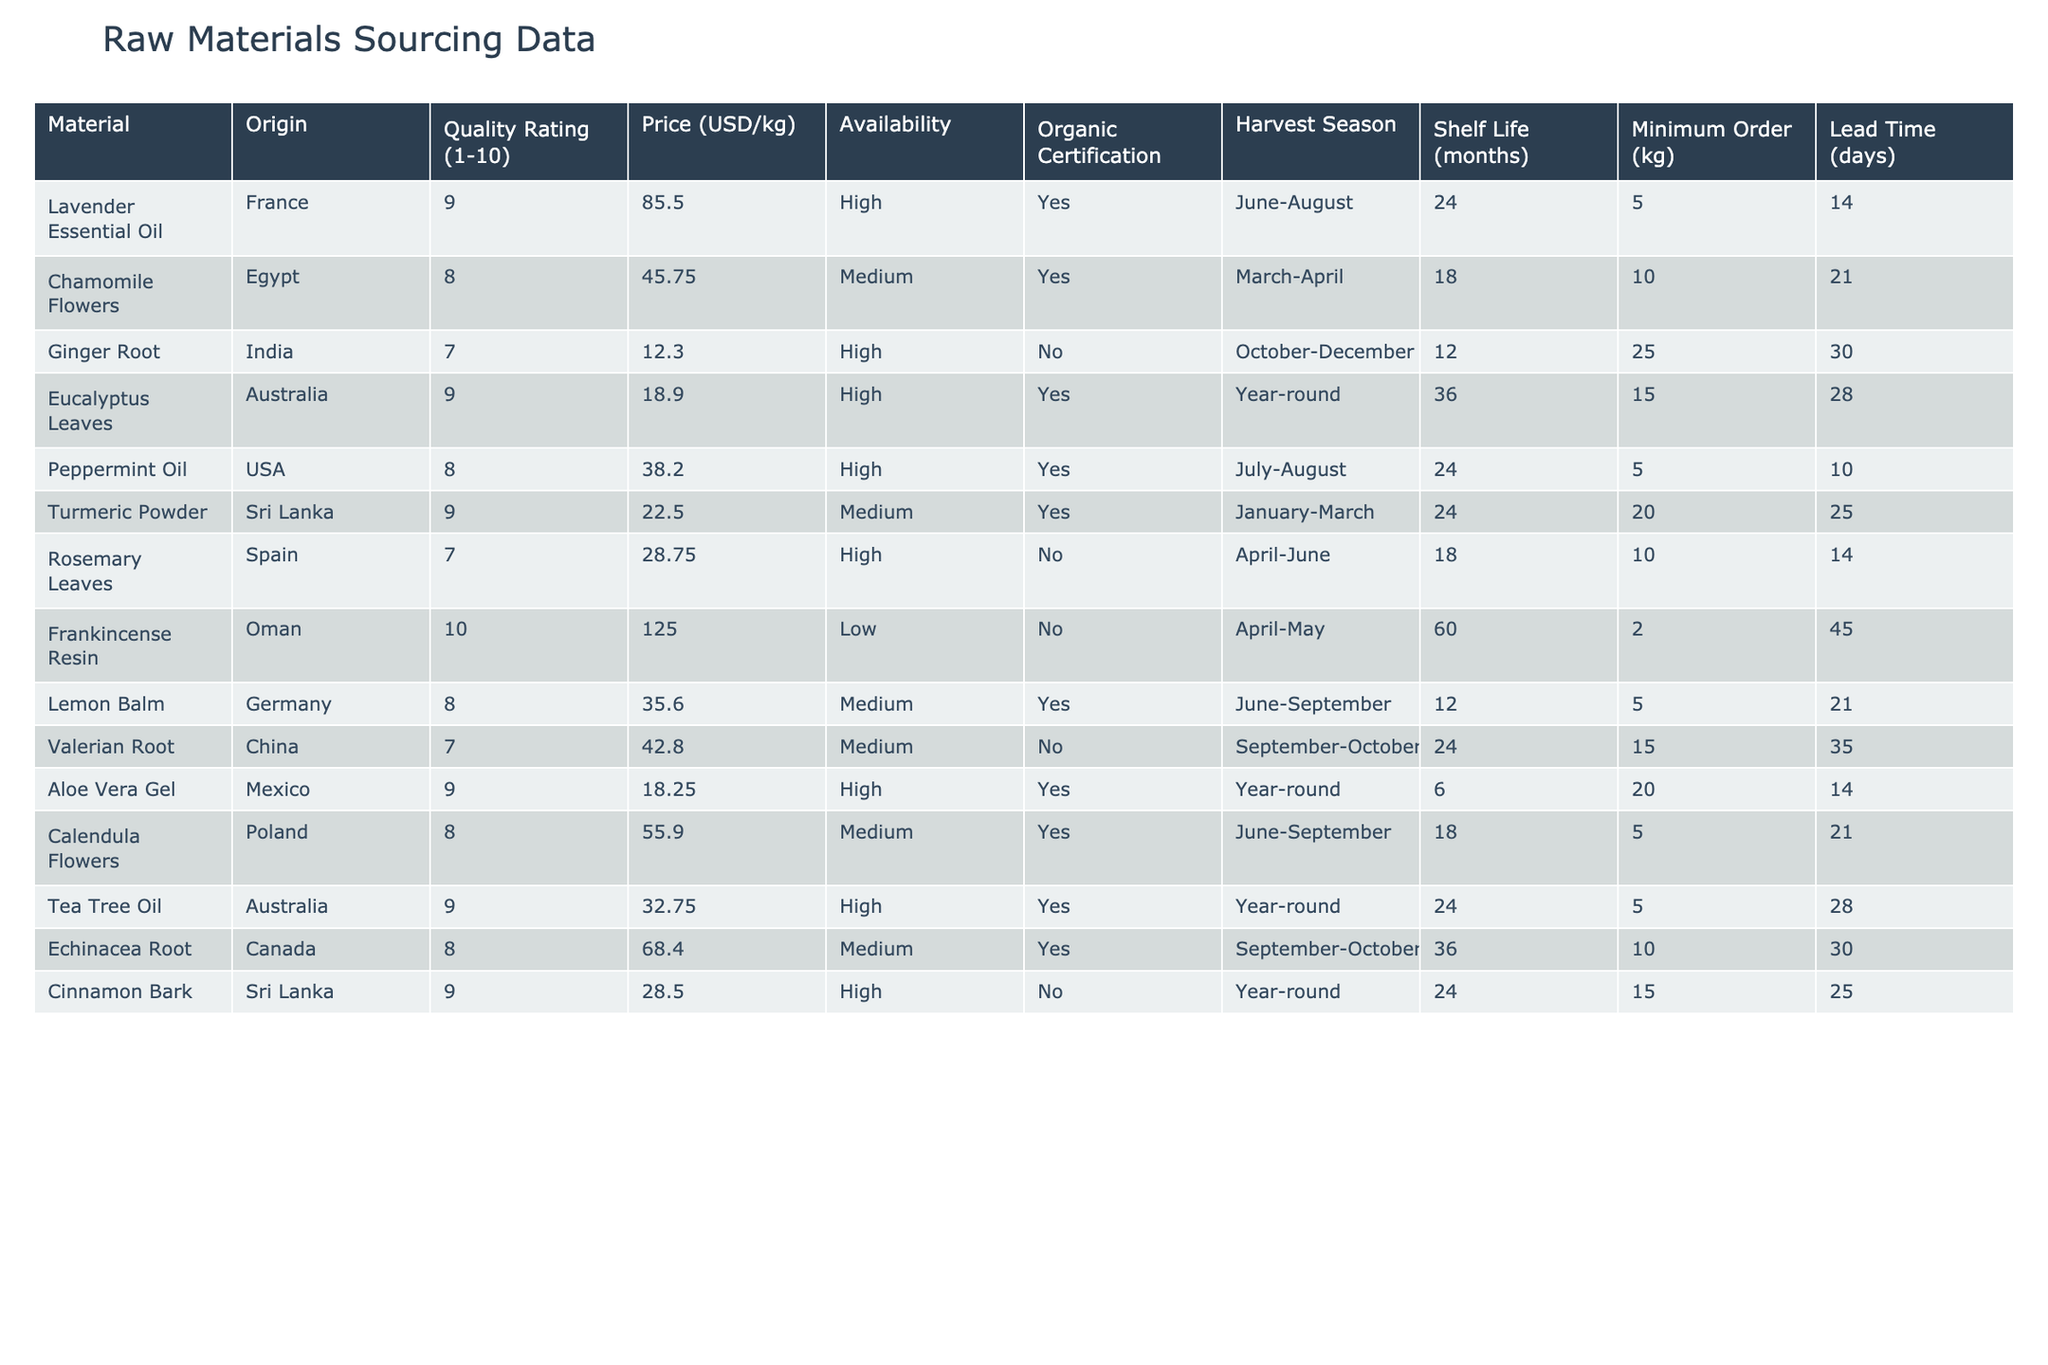What is the origin of Chamomile Flowers? The 'Origin' column specifies where each raw material comes from. In the row for Chamomile Flowers, it states 'Egypt' as the origin.
Answer: Egypt Which material has the highest quality rating? By examining the 'Quality Rating' column, we look for the maximum value, which is 10, associated with Frankincense Resin.
Answer: Frankincense Resin How many materials are certified organic? The 'Organic Certification' column contains 'Yes' or 'No' values. Counting the 'Yes' entries, we find there are 7 materials that are organic certified.
Answer: 7 What is the average price of materials with high availability? First, we identify materials with 'High' availability. The prices are Lavender Essential Oil ($85.50), Ginger Root ($12.30), Eucalyptus Leaves ($18.90), Peppermint Oil ($38.20), Aloe Vera Gel ($18.25), Cinnamon Bark ($28.50). Summing these gives $201.65, and dividing by 6 gives approximately $33.61.
Answer: 33.61 Is there any material with both high quality rating and organic certification? We check for materials with a quality rating of 8 or above and also 'Yes' under organic certification. The materials that fit this criteria are Lavender Essential Oil, Eucalyptus Leaves, Peppermint Oil, Aloe Vera Gel, and Tea Tree Oil. So, there are several such materials.
Answer: Yes Which material has the longest shelf life? By checking the 'Shelf Life' column, the highest value is 60 months for Frankincense Resin.
Answer: Frankincense Resin What is the minimum order quantity for materials from Sri Lanka? Reviewing the 'Minimum Order' column for materials from Sri Lanka, we find Turmeric Powder requires 20 kg and Cinnamon Bark requires 15 kg. The maximum of these is 20 kg.
Answer: 20 kg How many materials can be sourced year-round? The 'Harvest Season' column indicates which materials are available throughout the year. The materials with 'Year-round' are Eucalyptus Leaves, Aloe Vera Gel, and Tea Tree Oil, totaling 3 materials.
Answer: 3 What is the price difference between the highest and lowest quality rated materials? The highest quality rated material is Frankincense Resin priced at $125.00, and the lowest quality rated material is Valerian Root at $42.80. The difference is $125.00 - $42.80 = $82.20.
Answer: 82.20 Which material has the shortest lead time? By looking at the 'Lead Time' column, we see that the shortest lead time is 2 days for Frankincense Resin.
Answer: 2 days 